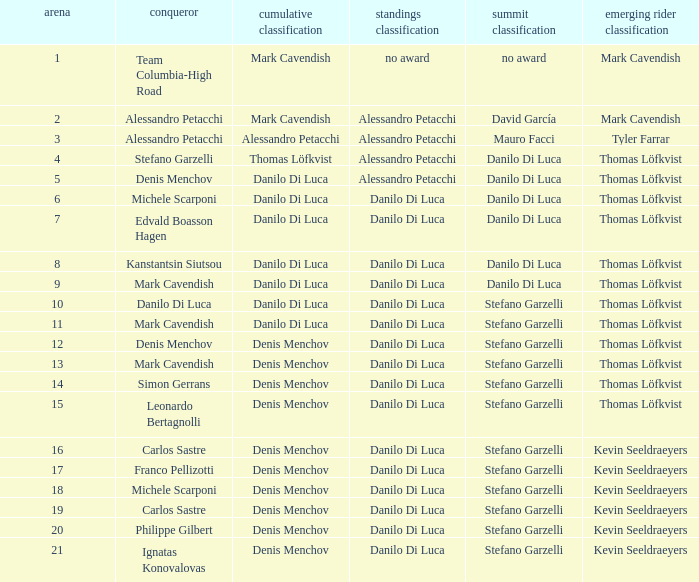When  thomas löfkvist is the general classification who is the winner? Stefano Garzelli. 